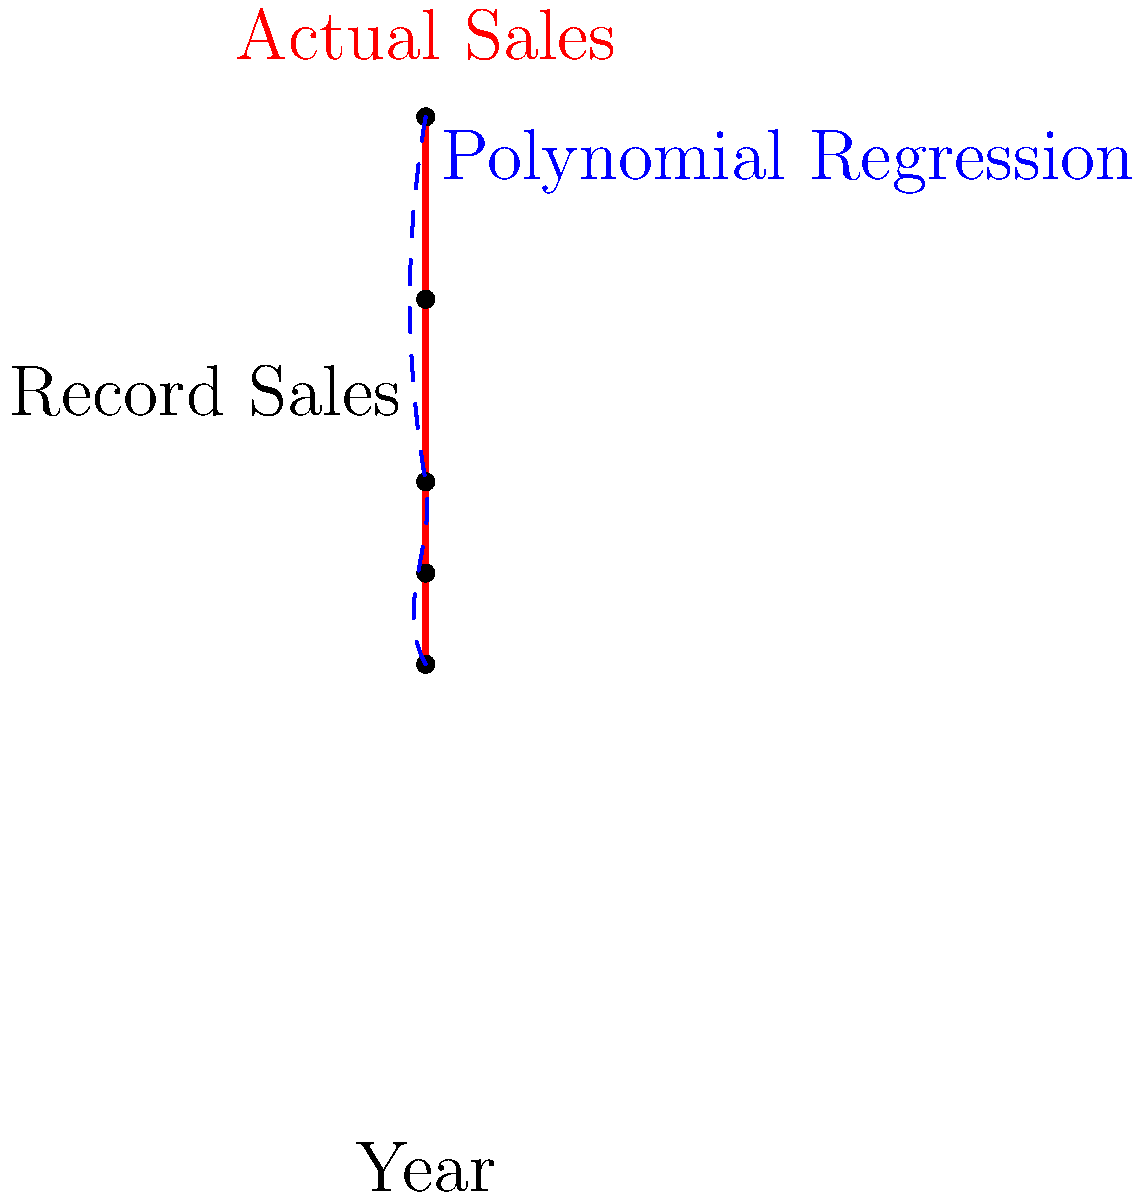Based on Peter Lemongello's record sales data from 1976 to 1980, a polynomial regression model has been fitted to predict future sales. According to this model, what is the most likely trend for Lemongello's record sales in the early 1980s? To answer this question, we need to analyze the given graph and understand the concept of polynomial regression:

1. The red dots and line represent Peter Lemongello's actual record sales from 1976 to 1980.
2. The blue dashed line represents the polynomial regression model fitted to this data.
3. We can observe that:
   a. The actual sales show a decreasing trend from 1976 to 1980.
   b. The polynomial regression curve follows this trend closely.
   c. The curve's slope becomes less steep as it approaches 1980.
4. To predict the trend for the early 1980s, we need to extrapolate the polynomial regression curve:
   a. The curve's slope is decreasing but still negative at 1980.
   b. This suggests that the sales will continue to decrease, but at a slower rate.
5. In polynomial regression, the curve can change direction. However, based on the visible portion of the curve, there's no indication of an imminent upturn.

Therefore, the most likely trend for Lemongello's record sales in the early 1980s, according to this polynomial regression model, is a continued decrease but at a diminishing rate.
Answer: Continued decrease at a diminishing rate 